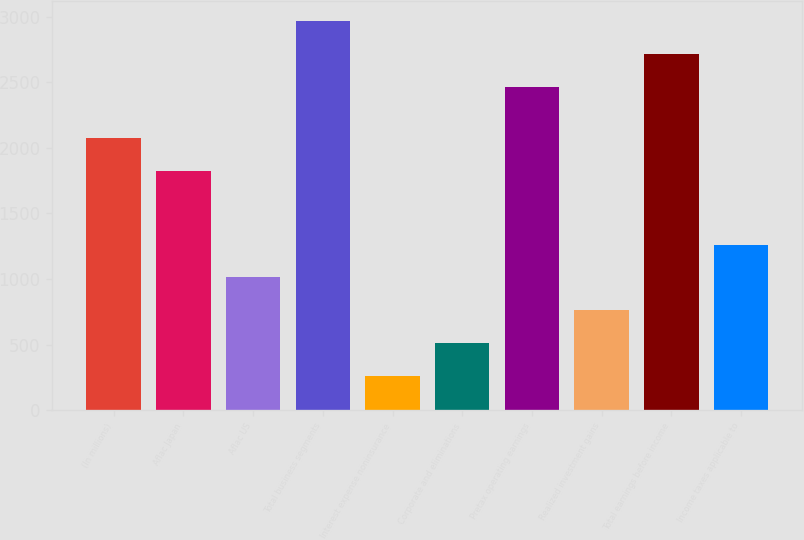<chart> <loc_0><loc_0><loc_500><loc_500><bar_chart><fcel>(In millions)<fcel>Aflac Japan<fcel>Aflac US<fcel>Total business segments<fcel>Interest expense noninsurance<fcel>Corporate and eliminations<fcel>Pretax operating earnings<fcel>Realized investment gains<fcel>Total earnings before income<fcel>Income taxes applicable to<nl><fcel>2071.2<fcel>1821<fcel>1011.8<fcel>2967.4<fcel>261.2<fcel>511.4<fcel>2467<fcel>761.6<fcel>2717.2<fcel>1262<nl></chart> 